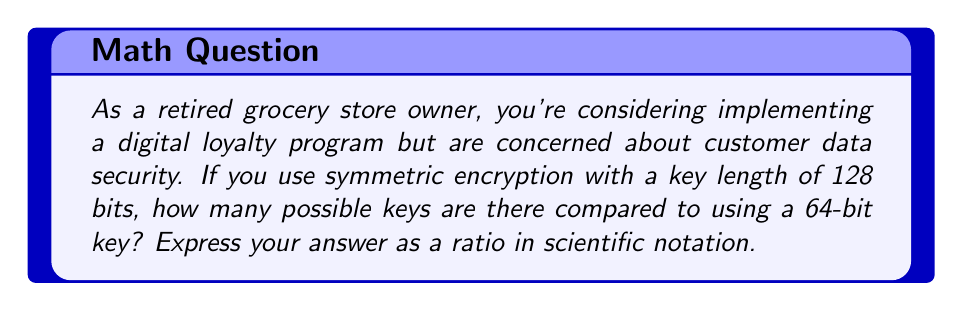Can you solve this math problem? Let's approach this step-by-step:

1) In symmetric encryption, the number of possible keys is determined by $2^n$, where $n$ is the number of bits in the key.

2) For a 128-bit key:
   Number of possible keys = $2^{128}$

3) For a 64-bit key:
   Number of possible keys = $2^{64}$

4) To find the ratio, we divide the number of keys for 128-bit encryption by the number of keys for 64-bit encryption:

   $$\frac{2^{128}}{2^{64}}$$

5) Using the laws of exponents, we can simplify this:

   $$2^{128-64} = 2^{64}$$

6) Now, $2^{64}$ is a very large number. To express it in scientific notation:

   $2^{64} = 18,446,744,073,709,551,616 \approx 1.8 \times 10^{19}$

Therefore, the 128-bit key provides approximately $1.8 \times 10^{19}$ times more possible keys than the 64-bit key.
Answer: $1.8 \times 10^{19}$ 